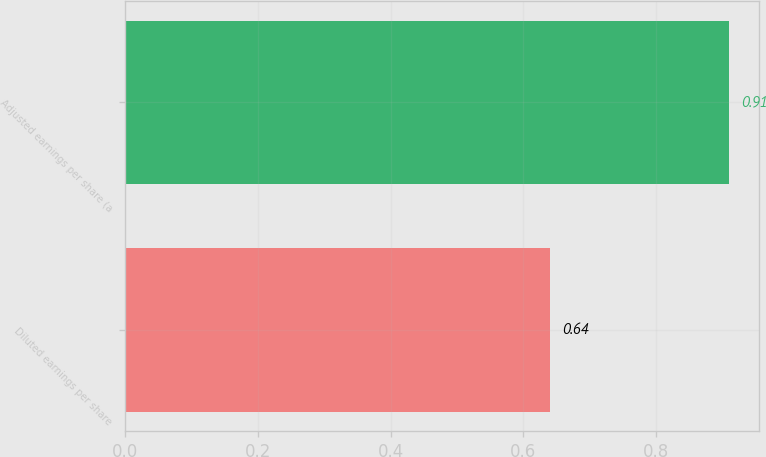Convert chart to OTSL. <chart><loc_0><loc_0><loc_500><loc_500><bar_chart><fcel>Diluted earnings per share<fcel>Adjusted earnings per share (a<nl><fcel>0.64<fcel>0.91<nl></chart> 